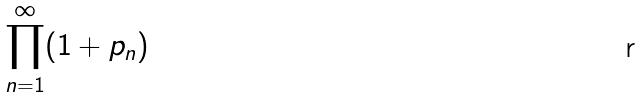Convert formula to latex. <formula><loc_0><loc_0><loc_500><loc_500>\prod _ { n = 1 } ^ { \infty } ( 1 + p _ { n } )</formula> 